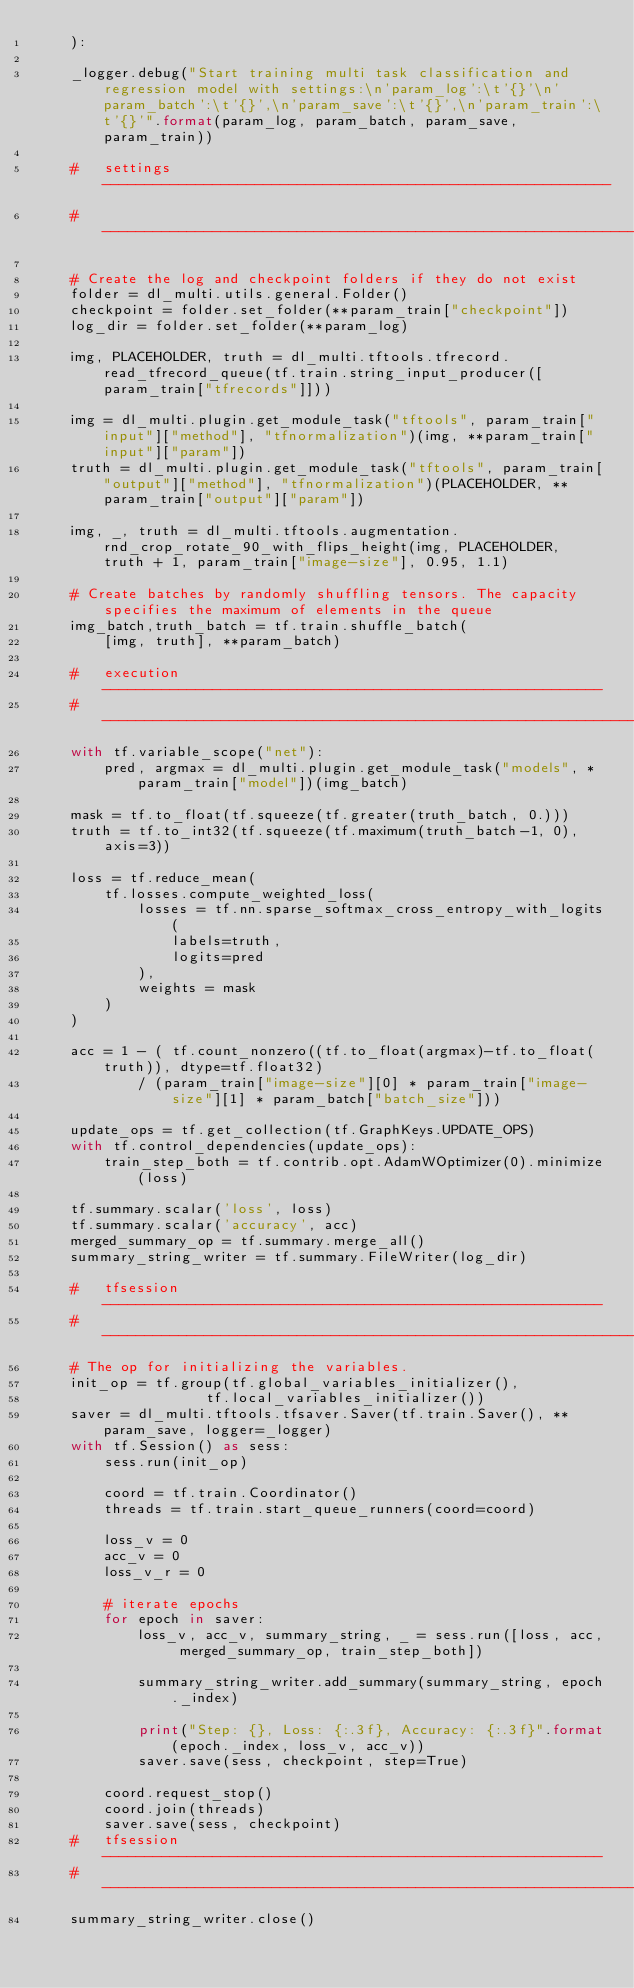<code> <loc_0><loc_0><loc_500><loc_500><_Python_>    ): 
    
    _logger.debug("Start training multi task classification and regression model with settings:\n'param_log':\t'{}'\n'param_batch':\t'{}',\n'param_save':\t'{}',\n'param_train':\t'{}'".format(param_log, param_batch, param_save,param_train))

    #   settings ------------------------------------------------------------
    # -----------------------------------------------------------------------

    # Create the log and checkpoint folders if they do not exist
    folder = dl_multi.utils.general.Folder()
    checkpoint = folder.set_folder(**param_train["checkpoint"])
    log_dir = folder.set_folder(**param_log)

    img, PLACEHOLDER, truth = dl_multi.tftools.tfrecord.read_tfrecord_queue(tf.train.string_input_producer([param_train["tfrecords"]]))

    img = dl_multi.plugin.get_module_task("tftools", param_train["input"]["method"], "tfnormalization")(img, **param_train["input"]["param"])
    truth = dl_multi.plugin.get_module_task("tftools", param_train["output"]["method"], "tfnormalization")(PLACEHOLDER, **param_train["output"]["param"])

    img, _, truth = dl_multi.tftools.augmentation.rnd_crop_rotate_90_with_flips_height(img, PLACEHOLDER, truth + 1, param_train["image-size"], 0.95, 1.1)

    # Create batches by randomly shuffling tensors. The capacity specifies the maximum of elements in the queue
    img_batch,truth_batch = tf.train.shuffle_batch(
        [img, truth], **param_batch)

    #   execution -----------------------------------------------------------
    # ----------------------------------------------------------------------- 
    with tf.variable_scope("net"):
        pred, argmax = dl_multi.plugin.get_module_task("models", *param_train["model"])(img_batch)

    mask = tf.to_float(tf.squeeze(tf.greater(truth_batch, 0.)))
    truth = tf.to_int32(tf.squeeze(tf.maximum(truth_batch-1, 0), axis=3))

    loss = tf.reduce_mean(
        tf.losses.compute_weighted_loss(
            losses = tf.nn.sparse_softmax_cross_entropy_with_logits(
                labels=truth, 
                logits=pred
            ),
            weights = mask
        )
    )

    acc = 1 - ( tf.count_nonzero((tf.to_float(argmax)-tf.to_float(truth)), dtype=tf.float32)
            / (param_train["image-size"][0] * param_train["image-size"][1] * param_batch["batch_size"]))

    update_ops = tf.get_collection(tf.GraphKeys.UPDATE_OPS)
    with tf.control_dependencies(update_ops):
        train_step_both = tf.contrib.opt.AdamWOptimizer(0).minimize(loss)
        
    tf.summary.scalar('loss', loss)
    tf.summary.scalar('accuracy', acc)
    merged_summary_op = tf.summary.merge_all()
    summary_string_writer = tf.summary.FileWriter(log_dir)

    #   tfsession -----------------------------------------------------------
    # -----------------------------------------------------------------------
    # The op for initializing the variables.
    init_op = tf.group(tf.global_variables_initializer(),
                    tf.local_variables_initializer()) 
    saver = dl_multi.tftools.tfsaver.Saver(tf.train.Saver(), **param_save, logger=_logger)
    with tf.Session() as sess:
        sess.run(init_op)
            
        coord = tf.train.Coordinator()
        threads = tf.train.start_queue_runners(coord=coord)
            
        loss_v = 0
        acc_v = 0
        loss_v_r = 0

        # iterate epochs
        for epoch in saver:
            loss_v, acc_v, summary_string, _ = sess.run([loss, acc, merged_summary_op, train_step_both])
            
            summary_string_writer.add_summary(summary_string, epoch._index)
                
            print("Step: {}, Loss: {:.3f}, Accuracy: {:.3f}".format(epoch._index, loss_v, acc_v))
            saver.save(sess, checkpoint, step=True)

        coord.request_stop()
        coord.join(threads)
        saver.save(sess, checkpoint)
    #   tfsession -----------------------------------------------------------
    # -----------------------------------------------------------------------
    summary_string_writer.close()</code> 